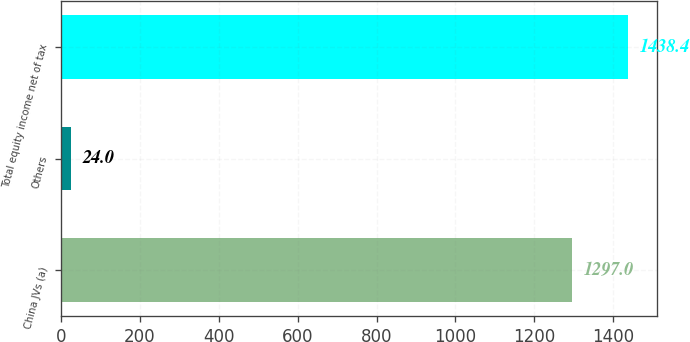<chart> <loc_0><loc_0><loc_500><loc_500><bar_chart><fcel>China JVs (a)<fcel>Others<fcel>Total equity income net of tax<nl><fcel>1297<fcel>24<fcel>1438.4<nl></chart> 